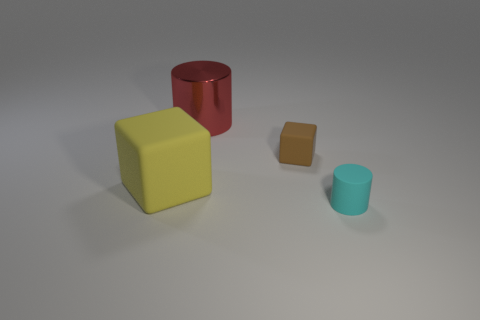Add 3 big red things. How many objects exist? 7 Subtract all brown cubes. How many cubes are left? 1 Subtract all big metallic balls. Subtract all small brown blocks. How many objects are left? 3 Add 4 big yellow blocks. How many big yellow blocks are left? 5 Add 2 purple matte blocks. How many purple matte blocks exist? 2 Subtract 0 brown spheres. How many objects are left? 4 Subtract all green cylinders. Subtract all green spheres. How many cylinders are left? 2 